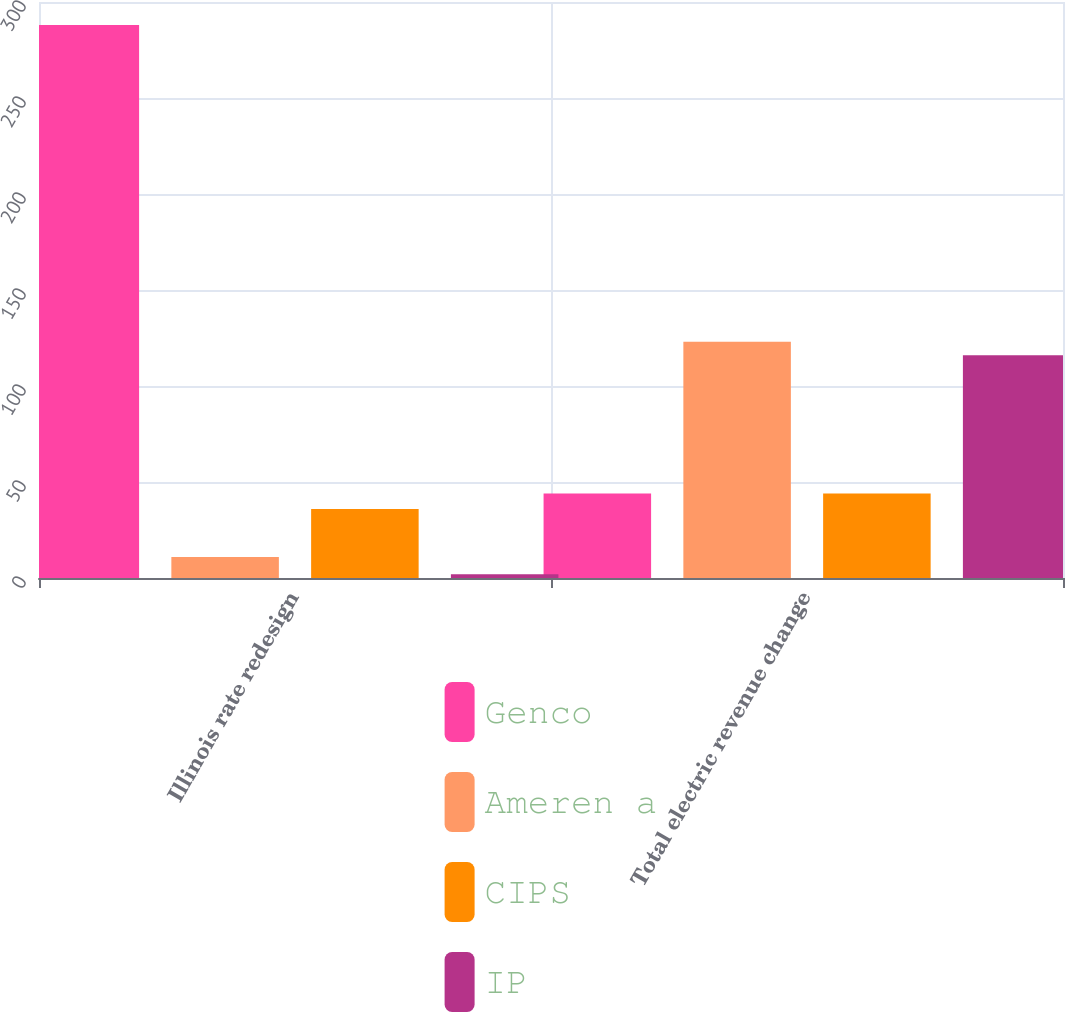Convert chart to OTSL. <chart><loc_0><loc_0><loc_500><loc_500><stacked_bar_chart><ecel><fcel>Illinois rate redesign<fcel>Total electric revenue change<nl><fcel>Genco<fcel>288<fcel>44<nl><fcel>Ameren a<fcel>11<fcel>123<nl><fcel>CIPS<fcel>36<fcel>44<nl><fcel>IP<fcel>2<fcel>116<nl></chart> 